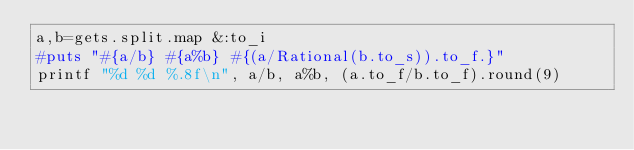<code> <loc_0><loc_0><loc_500><loc_500><_Ruby_>a,b=gets.split.map &:to_i
#puts "#{a/b} #{a%b} #{(a/Rational(b.to_s)).to_f.}"
printf "%d %d %.8f\n", a/b, a%b, (a.to_f/b.to_f).round(9)


</code> 